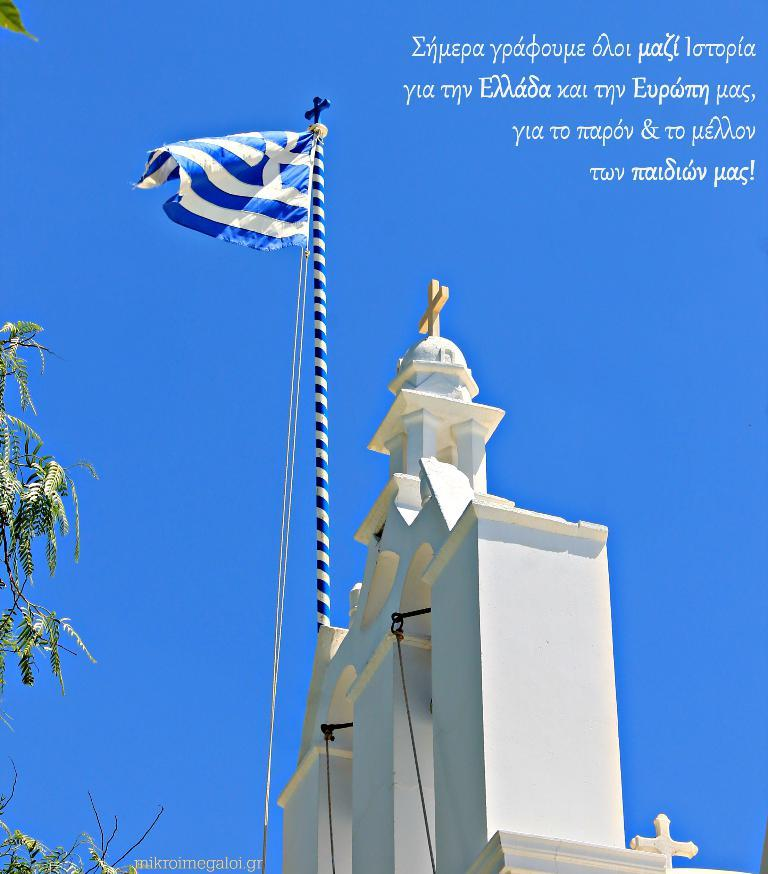What type of natural element can be seen in the image? There is a tree in the image. What symbol or emblem is present in the image? There is a flag in the image. What type of man-made structure is visible in the image? There is a building in the image. What part of the natural environment is visible in the image? The sky is visible in the image. What is written in the top right corner of the image? There is some matter written in the top right corner of the image. Where is the crate located in the image? There is no crate present in the image. What type of hook is attached to the flag in the image? There is no hook present in the image; the flag is simply visible. 